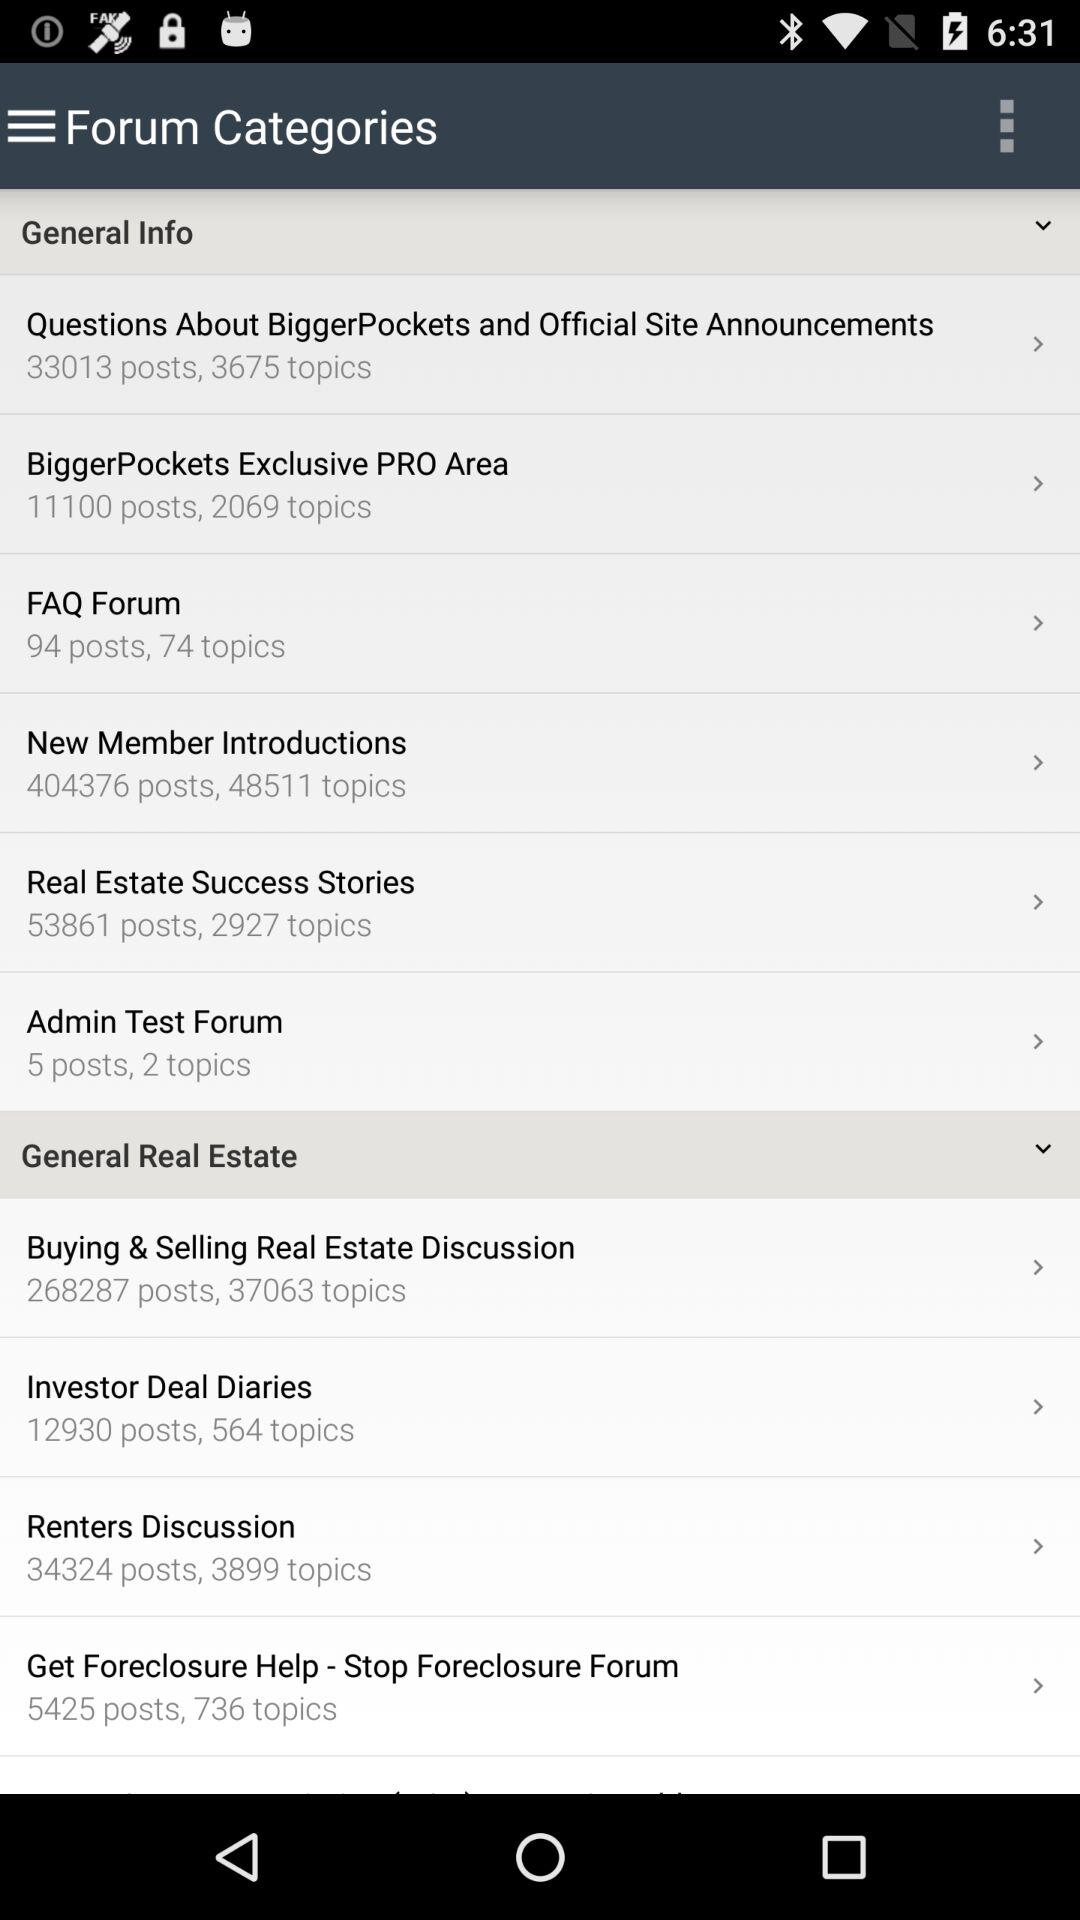What is the number of posts in the "FAQ Forum"? The number of posts in the "FAQ Forum" is 94. 